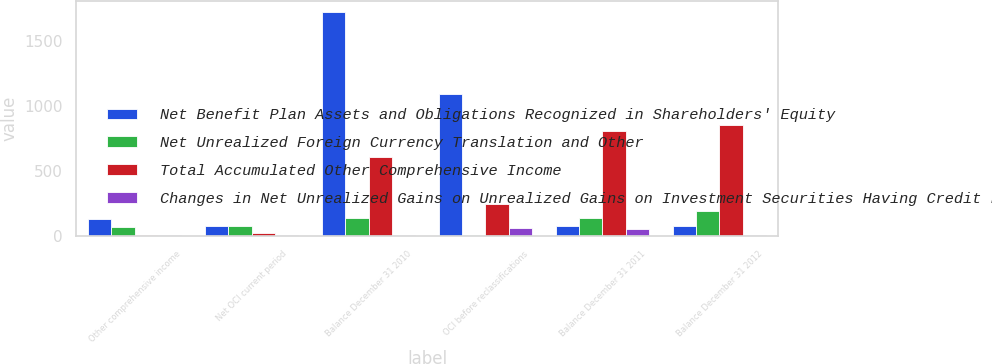Convert chart to OTSL. <chart><loc_0><loc_0><loc_500><loc_500><stacked_bar_chart><ecel><fcel>Other comprehensive income<fcel>Net OCI current period<fcel>Balance December 31 2010<fcel>OCI before reclassifications<fcel>Balance December 31 2011<fcel>Balance December 31 2012<nl><fcel>Net Benefit Plan Assets and Obligations Recognized in Shareholders' Equity<fcel>130<fcel>77<fcel>1719<fcel>1091<fcel>78.5<fcel>78.5<nl><fcel>Net Unrealized Foreign Currency Translation and Other<fcel>74<fcel>80<fcel>140<fcel>8<fcel>142<fcel>195<nl><fcel>Total Accumulated Other Comprehensive Income<fcel>13<fcel>27<fcel>610<fcel>251<fcel>811<fcel>857<nl><fcel>Changes in Net Unrealized Gains on Unrealized Gains on Investment Securities Having Credit Losses Recognized in the Consolidated<fcel>6<fcel>6<fcel>6<fcel>61<fcel>55<fcel>10<nl></chart> 